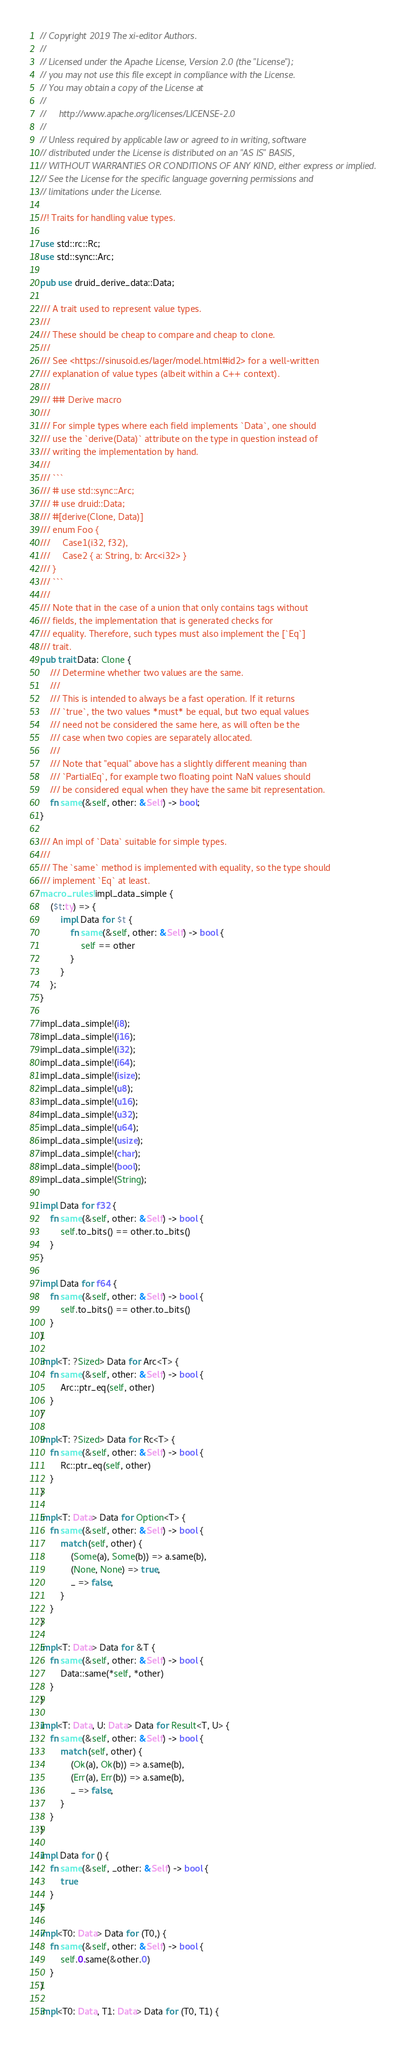Convert code to text. <code><loc_0><loc_0><loc_500><loc_500><_Rust_>// Copyright 2019 The xi-editor Authors.
//
// Licensed under the Apache License, Version 2.0 (the "License");
// you may not use this file except in compliance with the License.
// You may obtain a copy of the License at
//
//     http://www.apache.org/licenses/LICENSE-2.0
//
// Unless required by applicable law or agreed to in writing, software
// distributed under the License is distributed on an "AS IS" BASIS,
// WITHOUT WARRANTIES OR CONDITIONS OF ANY KIND, either express or implied.
// See the License for the specific language governing permissions and
// limitations under the License.

//! Traits for handling value types.

use std::rc::Rc;
use std::sync::Arc;

pub use druid_derive_data::Data;

/// A trait used to represent value types.
///
/// These should be cheap to compare and cheap to clone.
///
/// See <https://sinusoid.es/lager/model.html#id2> for a well-written
/// explanation of value types (albeit within a C++ context).
///
/// ## Derive macro
///
/// For simple types where each field implements `Data`, one should
/// use the `derive(Data)` attribute on the type in question instead of
/// writing the implementation by hand.
///
/// ```
/// # use std::sync::Arc;
/// # use druid::Data;
/// #[derive(Clone, Data)]
/// enum Foo {
///     Case1(i32, f32),
///     Case2 { a: String, b: Arc<i32> }
/// }
/// ```
///
/// Note that in the case of a union that only contains tags without
/// fields, the implementation that is generated checks for
/// equality. Therefore, such types must also implement the [`Eq`]
/// trait.
pub trait Data: Clone {
    /// Determine whether two values are the same.
    ///
    /// This is intended to always be a fast operation. If it returns
    /// `true`, the two values *must* be equal, but two equal values
    /// need not be considered the same here, as will often be the
    /// case when two copies are separately allocated.
    ///
    /// Note that "equal" above has a slightly different meaning than
    /// `PartialEq`, for example two floating point NaN values should
    /// be considered equal when they have the same bit representation.
    fn same(&self, other: &Self) -> bool;
}

/// An impl of `Data` suitable for simple types.
///
/// The `same` method is implemented with equality, so the type should
/// implement `Eq` at least.
macro_rules! impl_data_simple {
    ($t:ty) => {
        impl Data for $t {
            fn same(&self, other: &Self) -> bool {
                self == other
            }
        }
    };
}

impl_data_simple!(i8);
impl_data_simple!(i16);
impl_data_simple!(i32);
impl_data_simple!(i64);
impl_data_simple!(isize);
impl_data_simple!(u8);
impl_data_simple!(u16);
impl_data_simple!(u32);
impl_data_simple!(u64);
impl_data_simple!(usize);
impl_data_simple!(char);
impl_data_simple!(bool);
impl_data_simple!(String);

impl Data for f32 {
    fn same(&self, other: &Self) -> bool {
        self.to_bits() == other.to_bits()
    }
}

impl Data for f64 {
    fn same(&self, other: &Self) -> bool {
        self.to_bits() == other.to_bits()
    }
}

impl<T: ?Sized> Data for Arc<T> {
    fn same(&self, other: &Self) -> bool {
        Arc::ptr_eq(self, other)
    }
}

impl<T: ?Sized> Data for Rc<T> {
    fn same(&self, other: &Self) -> bool {
        Rc::ptr_eq(self, other)
    }
}

impl<T: Data> Data for Option<T> {
    fn same(&self, other: &Self) -> bool {
        match (self, other) {
            (Some(a), Some(b)) => a.same(b),
            (None, None) => true,
            _ => false,
        }
    }
}

impl<T: Data> Data for &T {
    fn same(&self, other: &Self) -> bool {
        Data::same(*self, *other)
    }
}

impl<T: Data, U: Data> Data for Result<T, U> {
    fn same(&self, other: &Self) -> bool {
        match (self, other) {
            (Ok(a), Ok(b)) => a.same(b),
            (Err(a), Err(b)) => a.same(b),
            _ => false,
        }
    }
}

impl Data for () {
    fn same(&self, _other: &Self) -> bool {
        true
    }
}

impl<T0: Data> Data for (T0,) {
    fn same(&self, other: &Self) -> bool {
        self.0.same(&other.0)
    }
}

impl<T0: Data, T1: Data> Data for (T0, T1) {</code> 